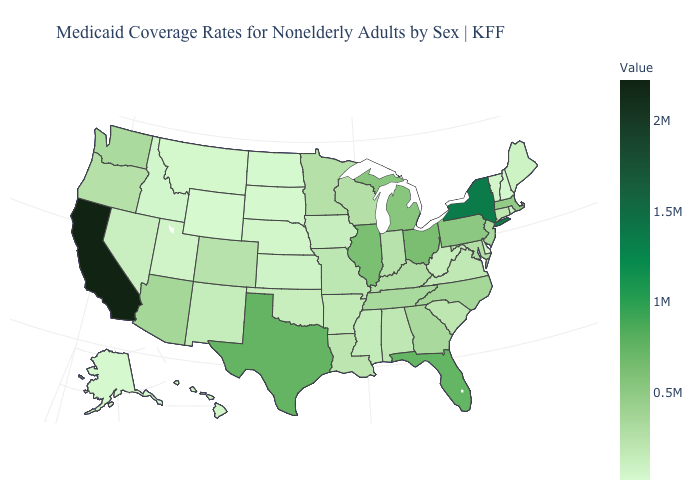Among the states that border Delaware , does Pennsylvania have the highest value?
Quick response, please. Yes. Among the states that border Washington , which have the lowest value?
Quick response, please. Idaho. Does the map have missing data?
Write a very short answer. No. Which states have the lowest value in the USA?
Give a very brief answer. Wyoming. Does Mississippi have a lower value than Florida?
Keep it brief. Yes. Does Michigan have a lower value than New York?
Give a very brief answer. Yes. Does Nebraska have the lowest value in the MidWest?
Answer briefly. No. 